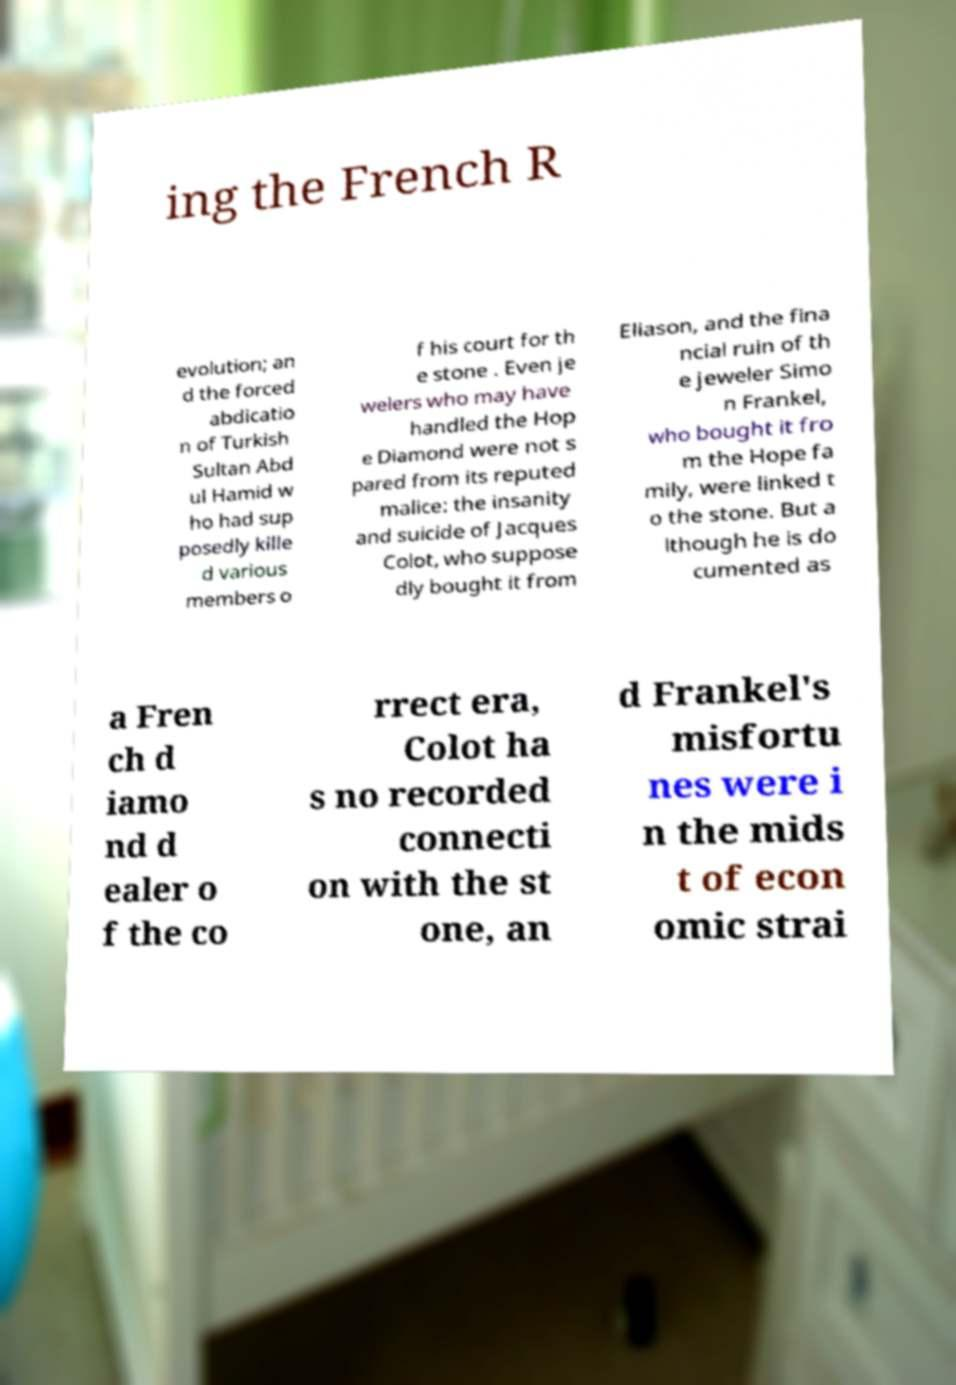I need the written content from this picture converted into text. Can you do that? ing the French R evolution; an d the forced abdicatio n of Turkish Sultan Abd ul Hamid w ho had sup posedly kille d various members o f his court for th e stone . Even je welers who may have handled the Hop e Diamond were not s pared from its reputed malice: the insanity and suicide of Jacques Colot, who suppose dly bought it from Eliason, and the fina ncial ruin of th e jeweler Simo n Frankel, who bought it fro m the Hope fa mily, were linked t o the stone. But a lthough he is do cumented as a Fren ch d iamo nd d ealer o f the co rrect era, Colot ha s no recorded connecti on with the st one, an d Frankel's misfortu nes were i n the mids t of econ omic strai 